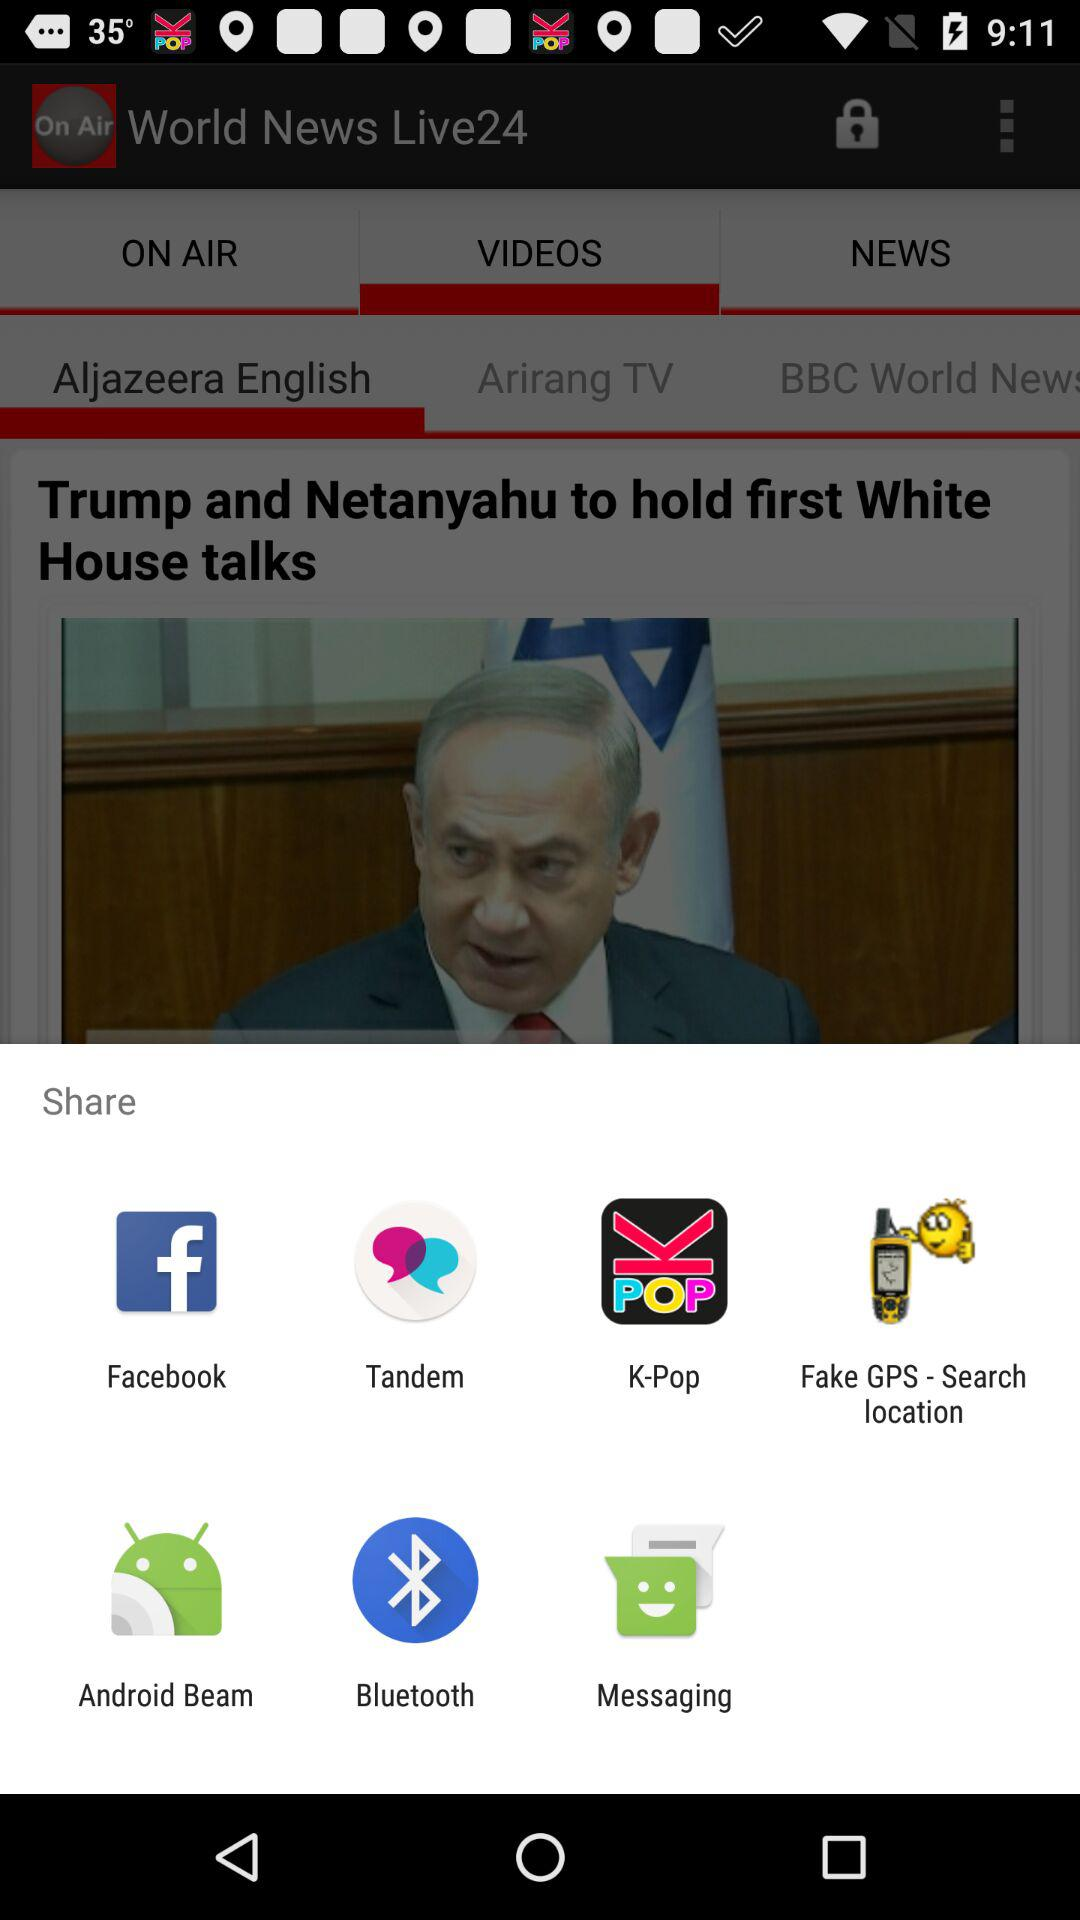Who is on air now?
When the provided information is insufficient, respond with <no answer>. <no answer> 